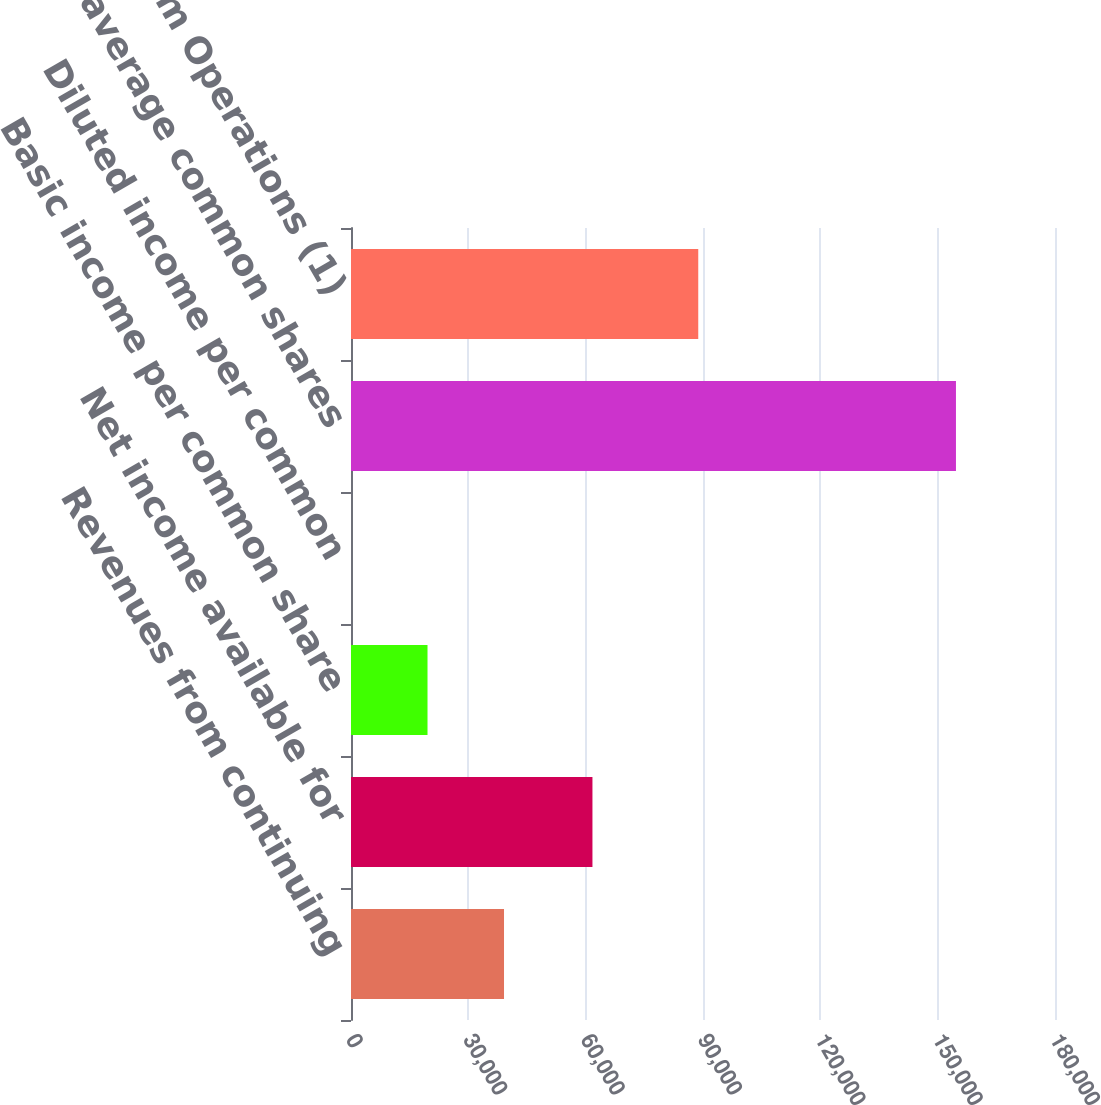<chart> <loc_0><loc_0><loc_500><loc_500><bar_chart><fcel>Revenues from continuing<fcel>Net income available for<fcel>Basic income per common share<fcel>Diluted income per common<fcel>Weighted average common shares<fcel>Funds From Operations (1)<nl><fcel>39123.2<fcel>61734<fcel>19561.8<fcel>0.45<fcel>154678<fcel>88787<nl></chart> 